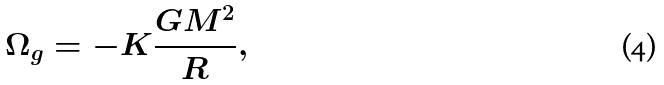Convert formula to latex. <formula><loc_0><loc_0><loc_500><loc_500>\Omega _ { g } = - K \frac { G M ^ { 2 } } { R } ,</formula> 